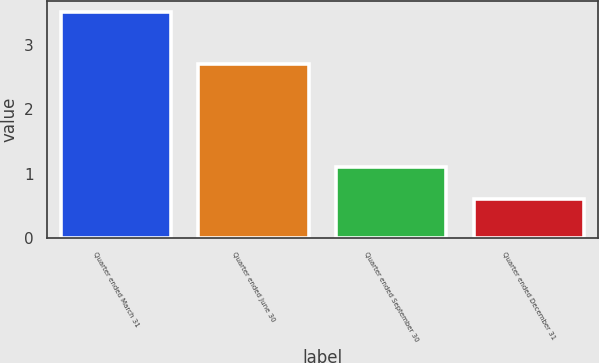Convert chart. <chart><loc_0><loc_0><loc_500><loc_500><bar_chart><fcel>Quarter ended March 31<fcel>Quarter ended June 30<fcel>Quarter ended September 30<fcel>Quarter ended December 31<nl><fcel>3.5<fcel>2.7<fcel>1.1<fcel>0.6<nl></chart> 